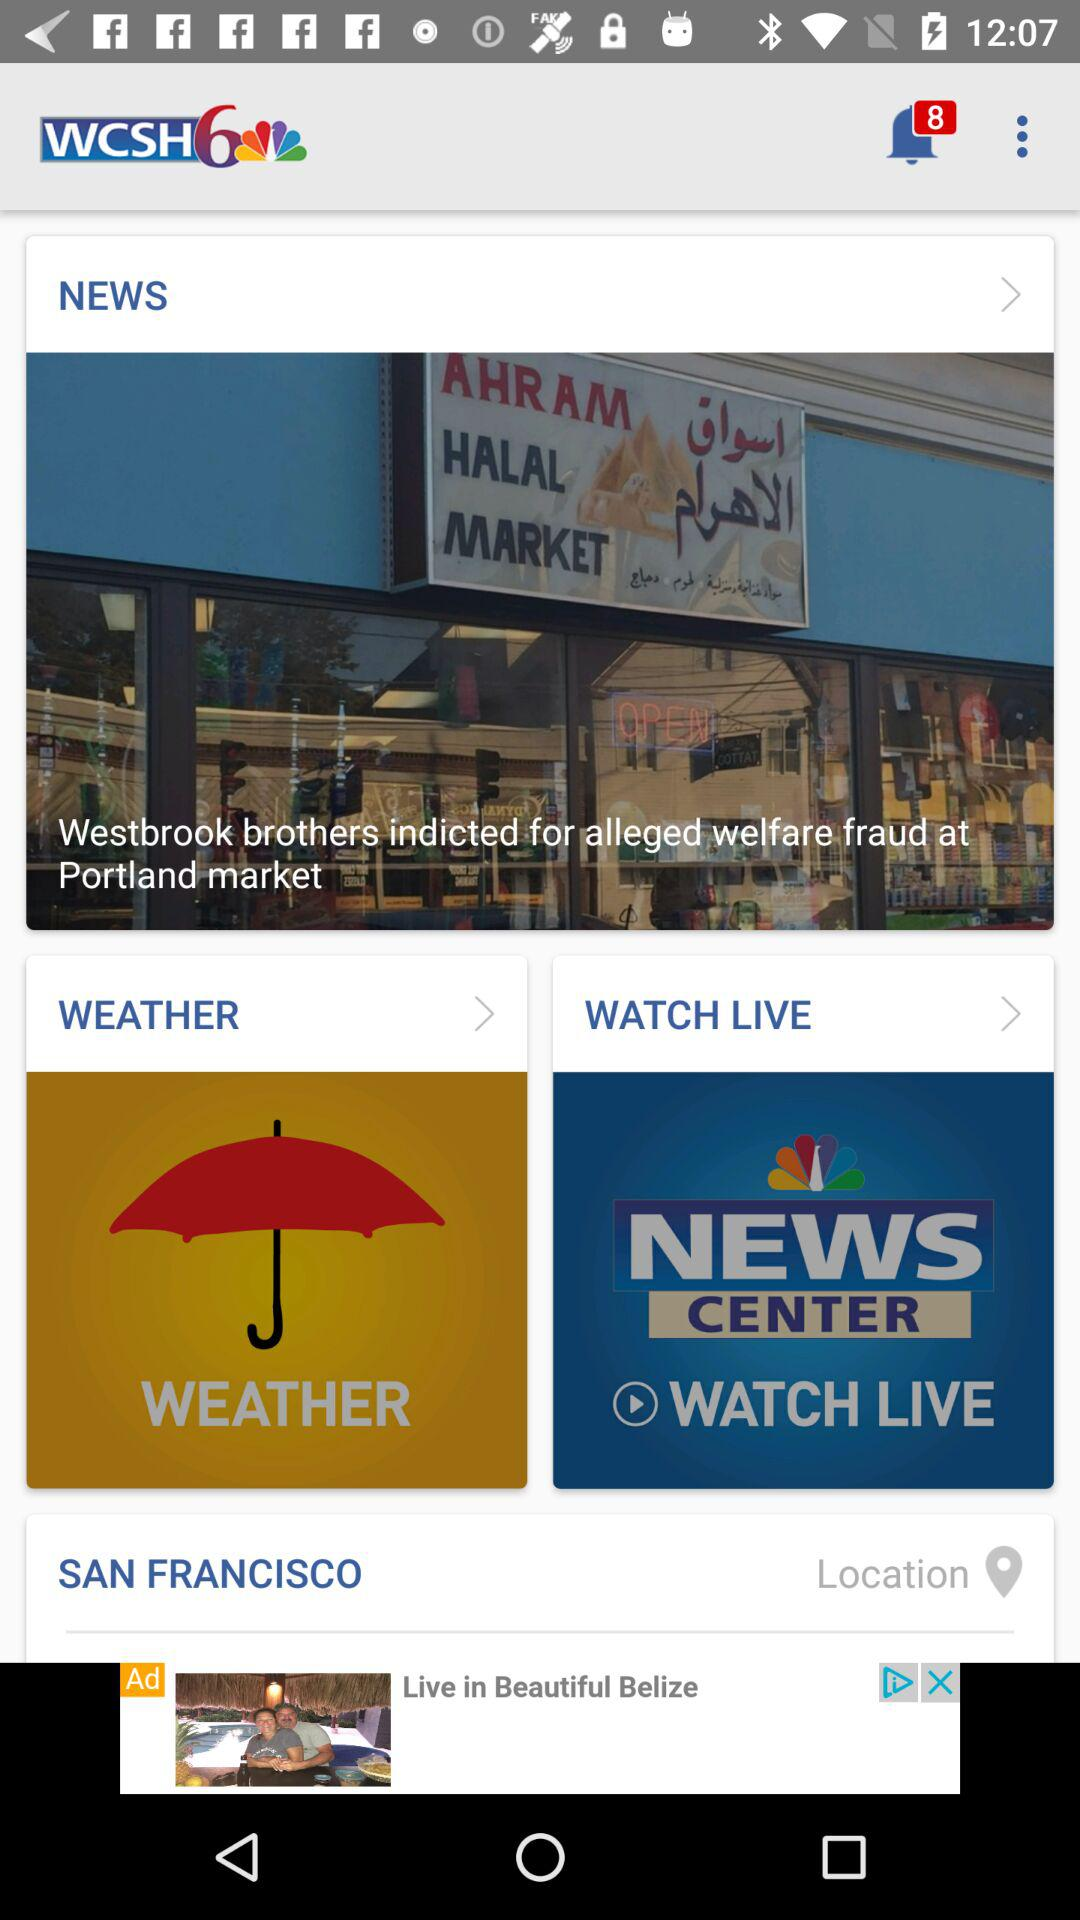How many unread notifications are there? There are 8 unread notifications. 